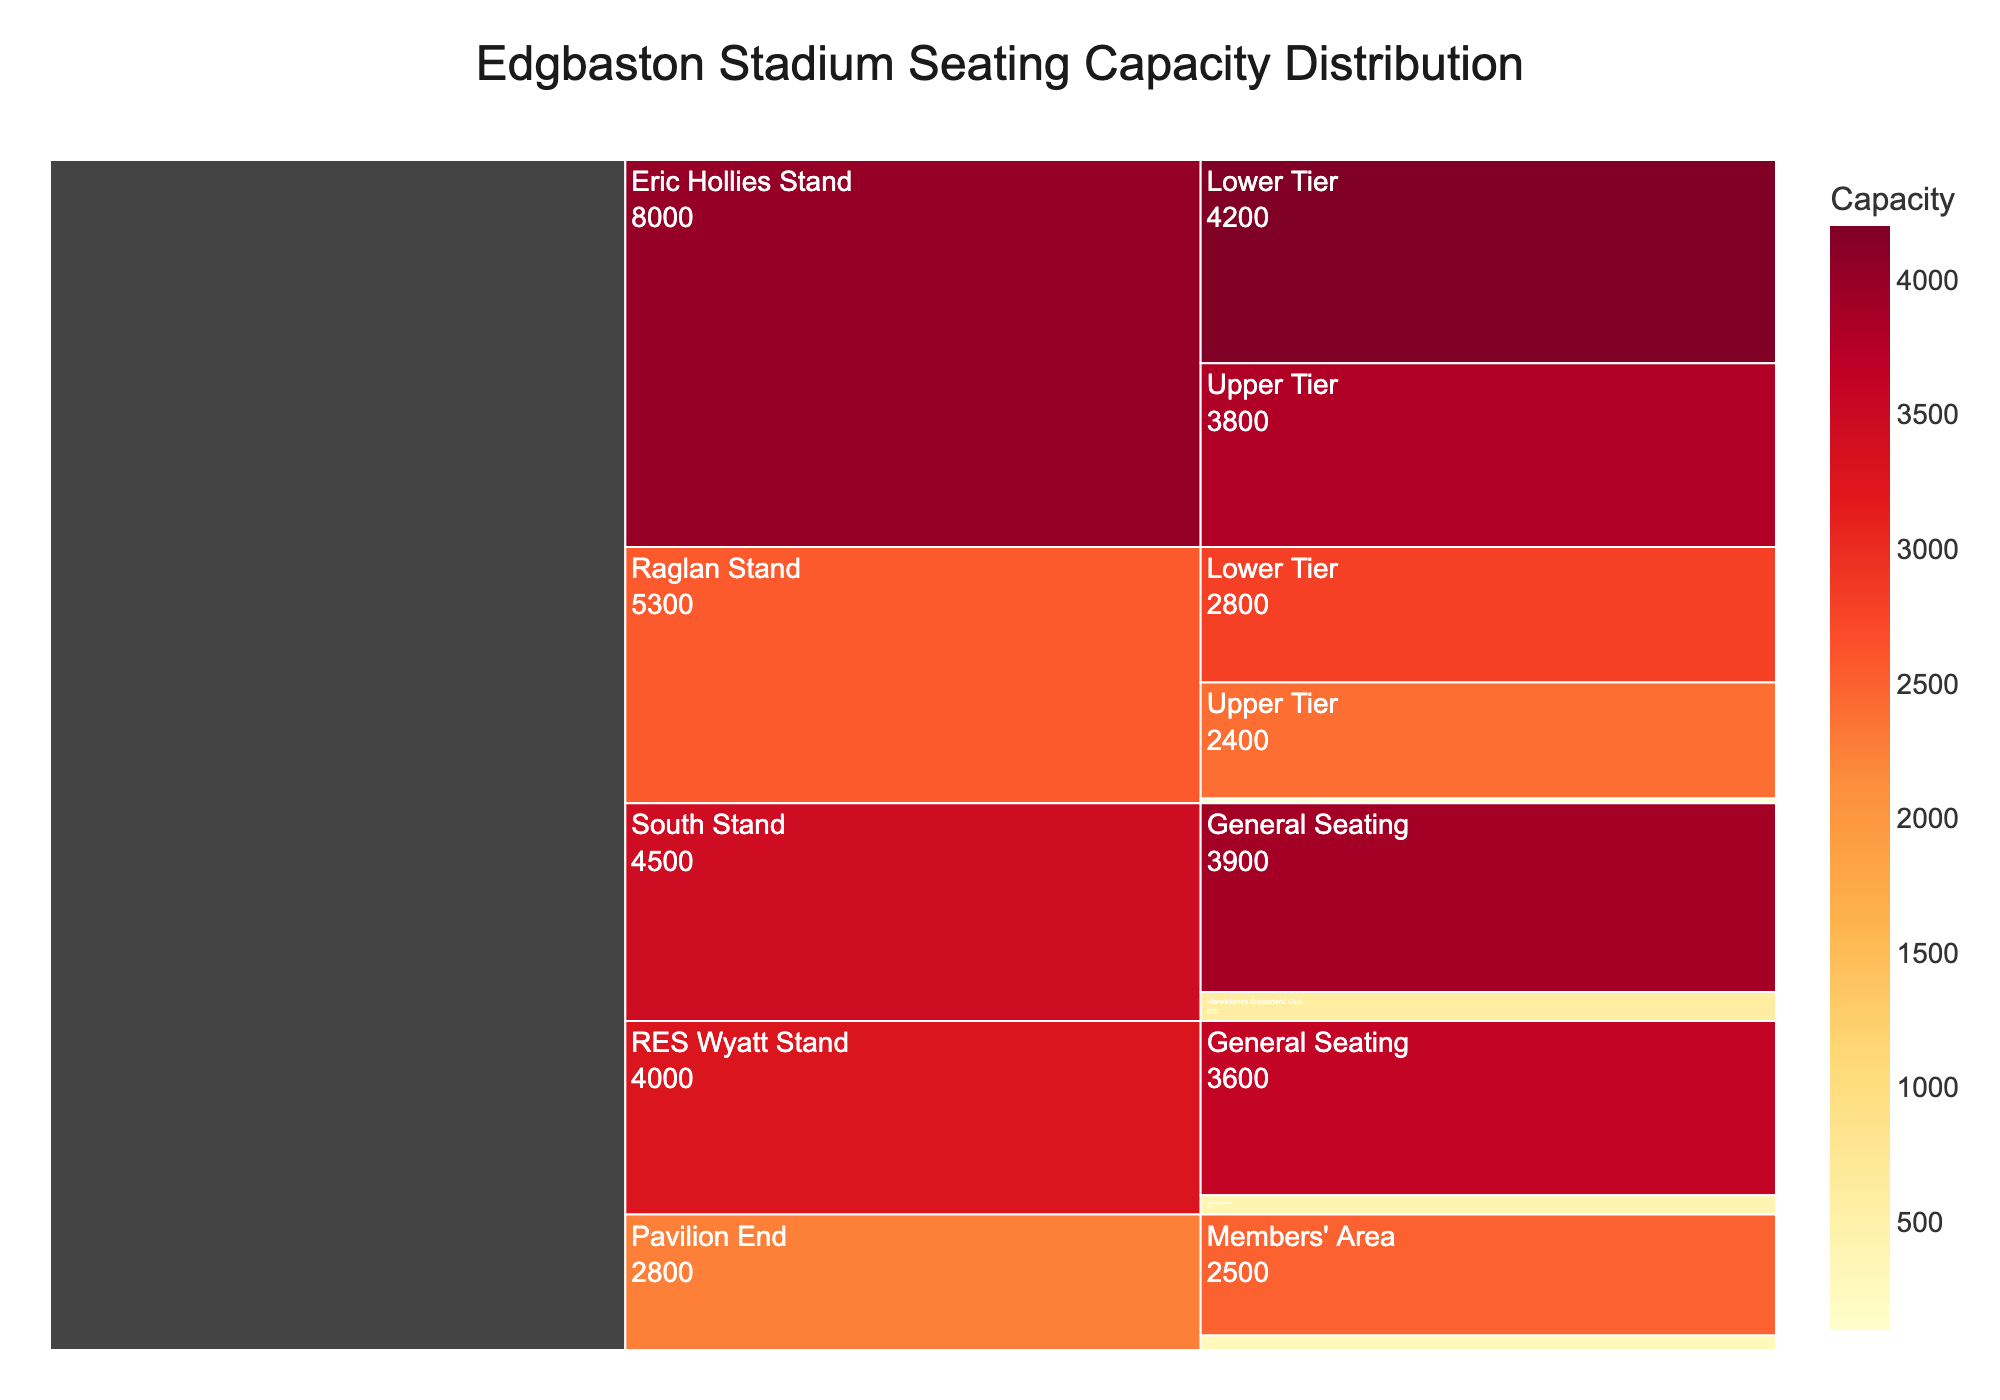What is the total seating capacity of the Edgbaston Stadium mentioned in the chart? To find the total seating capacity, you need to sum up the capacities listed for each section in the chart. Add the values: 4200 + 3800 + 2500 + 300 + 3600 + 400 + 2800 + 2400 + 100 + 3900 + 600 = 24500
Answer: 24500 Which stand has the highest seating capacity when combining all its sections? To determine the stand with the highest seating capacity, sum the capacities of each stand and compare. Eric Hollies Stand: 4200 + 3800 = 8000; Pavilion End: 2500 + 300 = 2800; RES Wyatt Stand: 3600 + 400 = 4000; Raglan Stand: 2800 + 2400 + 100 = 5300; South Stand: 3900 + 600 = 4500. Eric Hollies Stand has the highest capacity with 8000 seats
Answer: Eric Hollies Stand What is the ratio of lower tier to upper tier seating in the Raglan Stand? To find the ratio of lower tier to upper tier seating in the Raglan Stand, divide the capacity of the lower tier by that of the upper tier: 2800/2400 = 1.167
Answer: 1.167 Which stand has the smallest single section in terms of seating capacity, and which section is it? Compare the capacities of all the sections. The smallest is the Press Box in the Raglan Stand with 100 seats
Answer: Raglan Stand, Press Box How much more seating capacity does the Eric Hollies Stand have compared to the Pavilion End? Subtract the total seating capacity of the Pavilion End from the total seating capacity of the Eric Hollies Stand. 8000 - 2800 = 5200
Answer: 5200 Is the seating capacity of the Members' Area in the Pavilion End greater than the General Seating in the RES Wyatt Stand? Compare the capacities of the Members' Area (2500) and the General Seating in the RES Wyatt Stand (3600). 2500 is not greater than 3600
Answer: No What percentage of the total seating capacity is represented by the Lower Tier of the Eric Hollies Stand? Calculate the percentage by dividing the Lower Tier seating capacity of the Eric Hollies Stand by the total seating capacity and multiplying by 100. (4200/24500) * 100 = 17.14%
Answer: 17.14% How many sections does the chart display overall? Count the number of unique sections listed in the chart: Lower Tier, Upper Tier, Members' Area, Chairman's Lounge, General Seating, Warwickshire Suite, Press Box, Warwickshire Supporters' Club. There are 8 sections
Answer: 8 